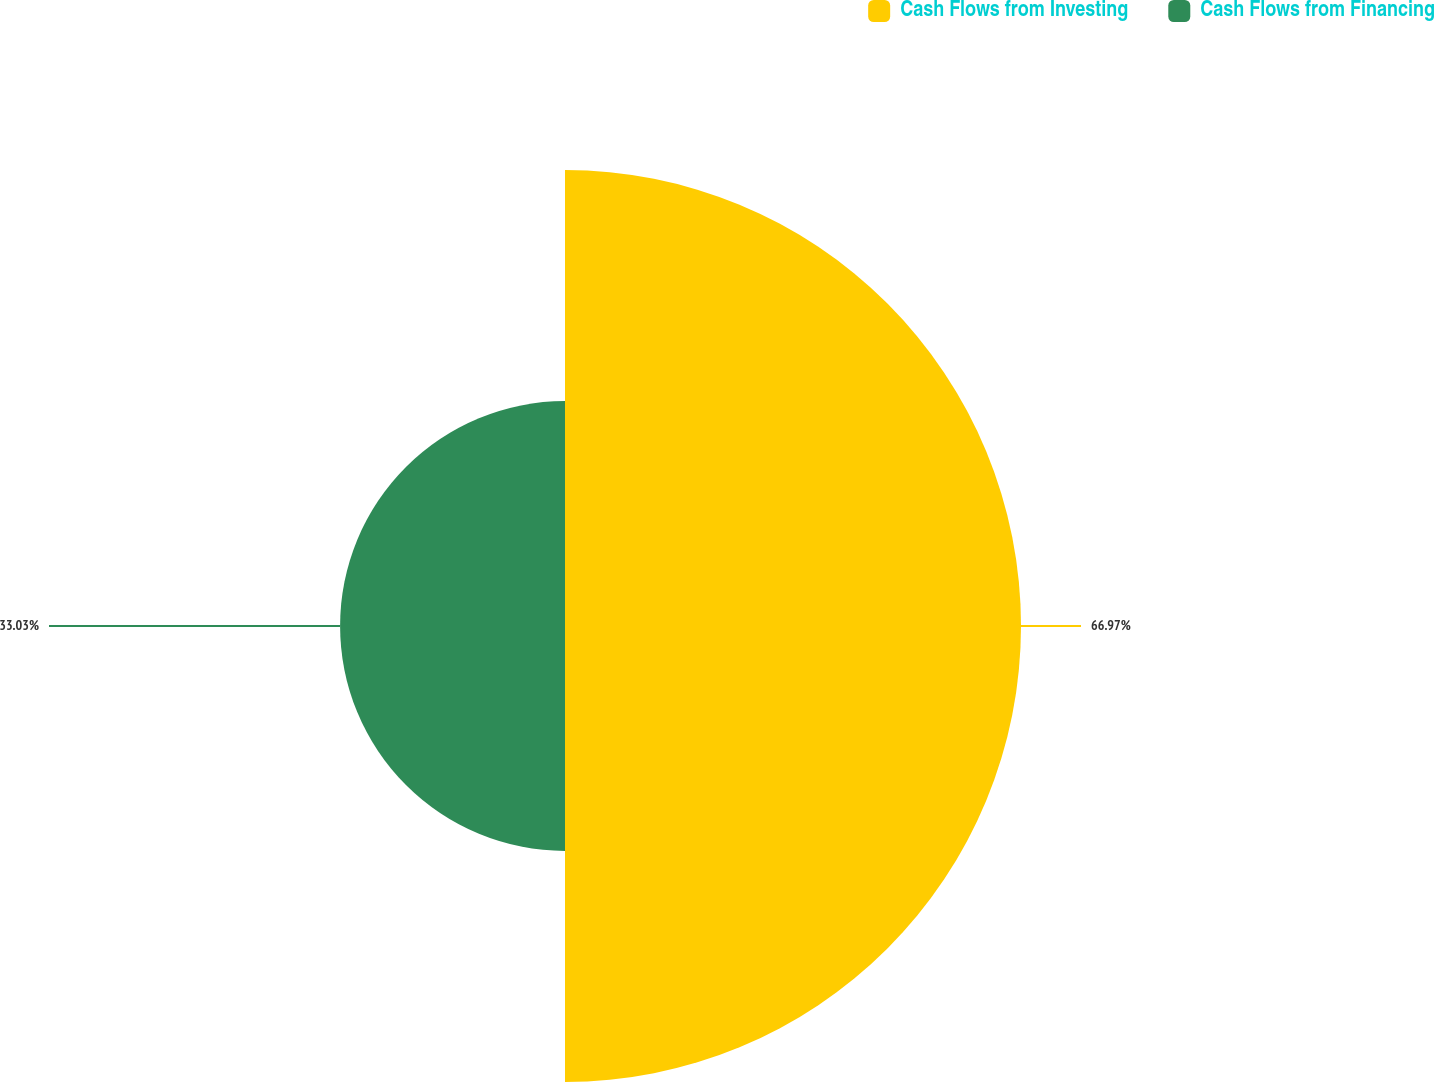<chart> <loc_0><loc_0><loc_500><loc_500><pie_chart><fcel>Cash Flows from Investing<fcel>Cash Flows from Financing<nl><fcel>66.97%<fcel>33.03%<nl></chart> 